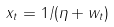Convert formula to latex. <formula><loc_0><loc_0><loc_500><loc_500>x _ { t } = 1 / ( \eta + w _ { t } )</formula> 